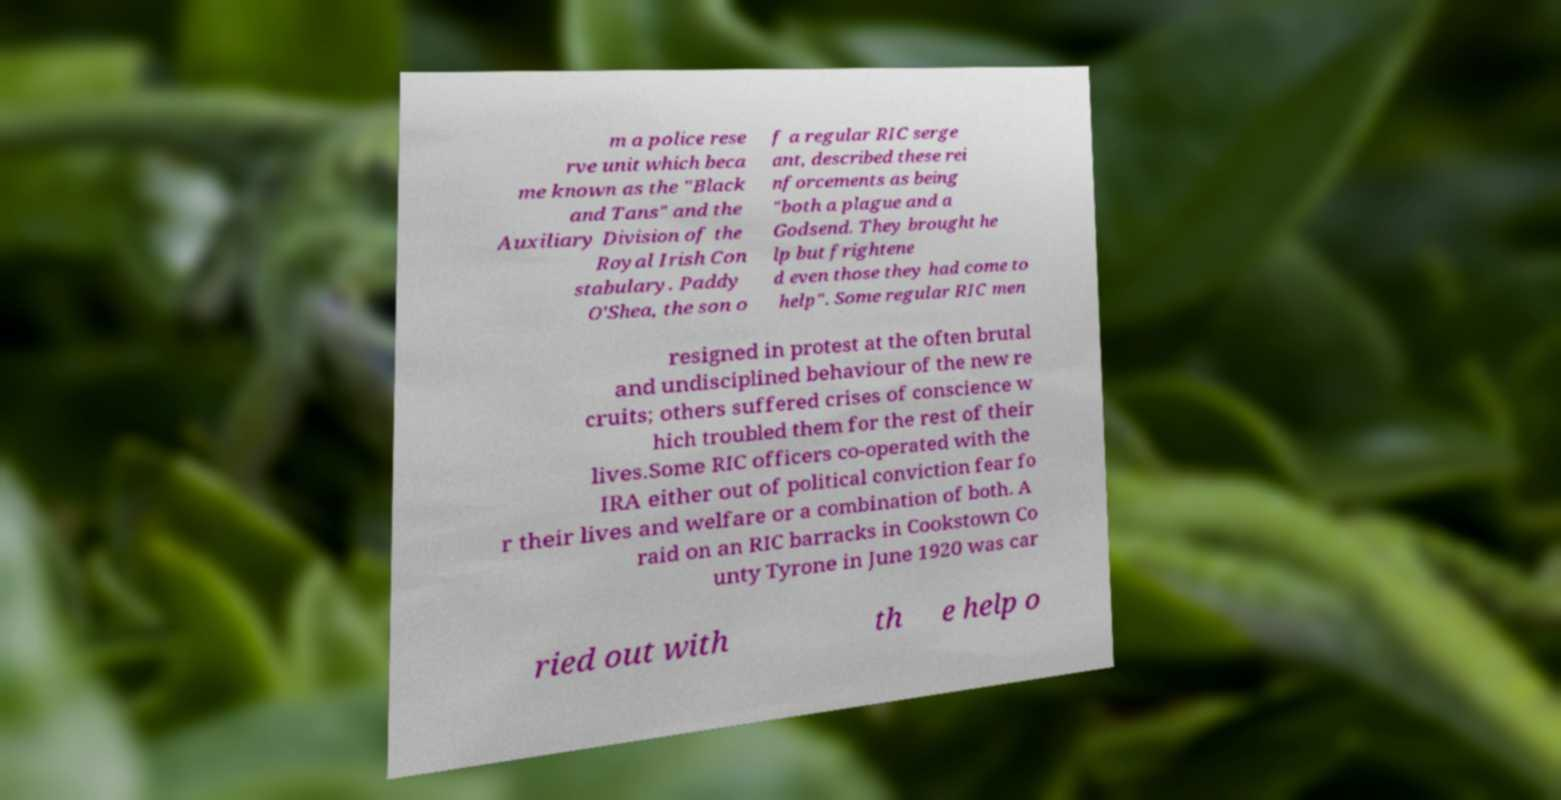Please read and relay the text visible in this image. What does it say? m a police rese rve unit which beca me known as the "Black and Tans" and the Auxiliary Division of the Royal Irish Con stabulary. Paddy O'Shea, the son o f a regular RIC serge ant, described these rei nforcements as being "both a plague and a Godsend. They brought he lp but frightene d even those they had come to help". Some regular RIC men resigned in protest at the often brutal and undisciplined behaviour of the new re cruits; others suffered crises of conscience w hich troubled them for the rest of their lives.Some RIC officers co-operated with the IRA either out of political conviction fear fo r their lives and welfare or a combination of both. A raid on an RIC barracks in Cookstown Co unty Tyrone in June 1920 was car ried out with th e help o 